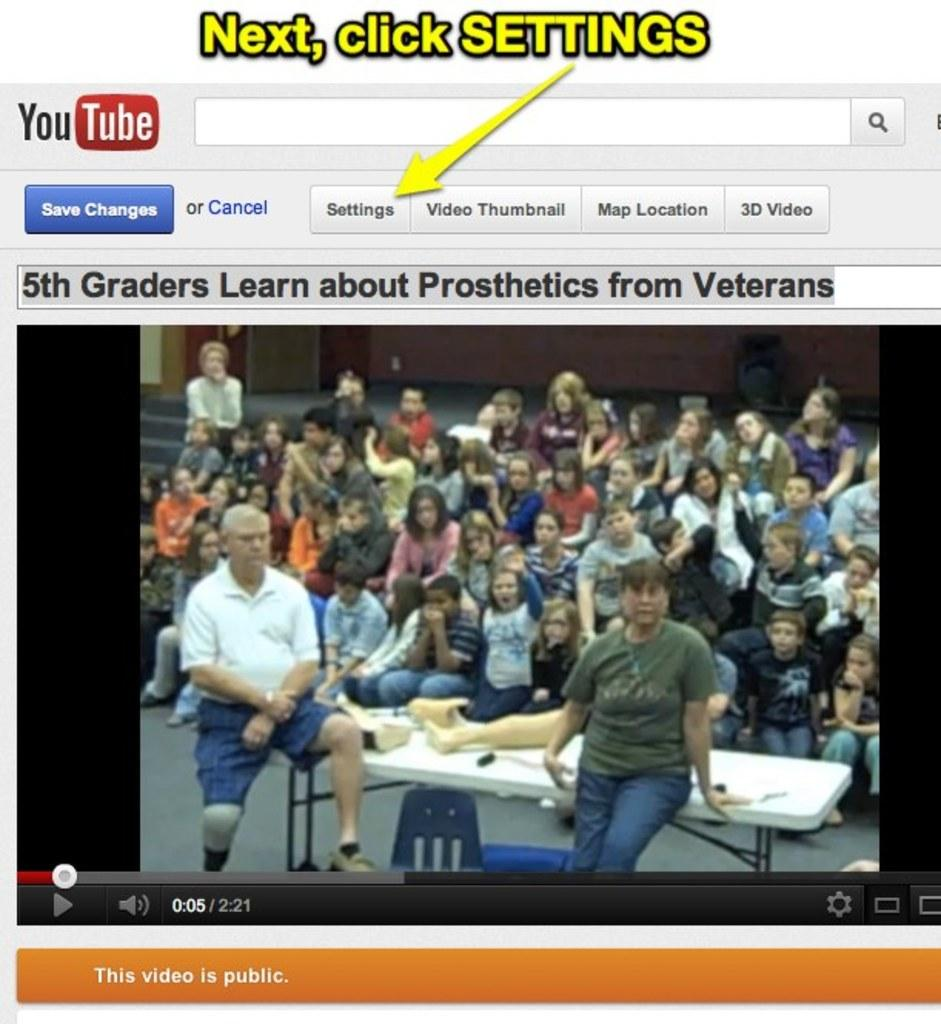What type of image is being described? The image is a screenshot. How many people can be seen in the image? There are multiple persons visible in the image. What are two persons doing in the image? Two persons are sitting on a table. Who is wearing a crown in the image? There is no one wearing a crown in the image. What type of surface are the two persons sitting on in the image? The provided facts do not specify the type of surface the two persons are sitting on, only that they are sitting on a table. 